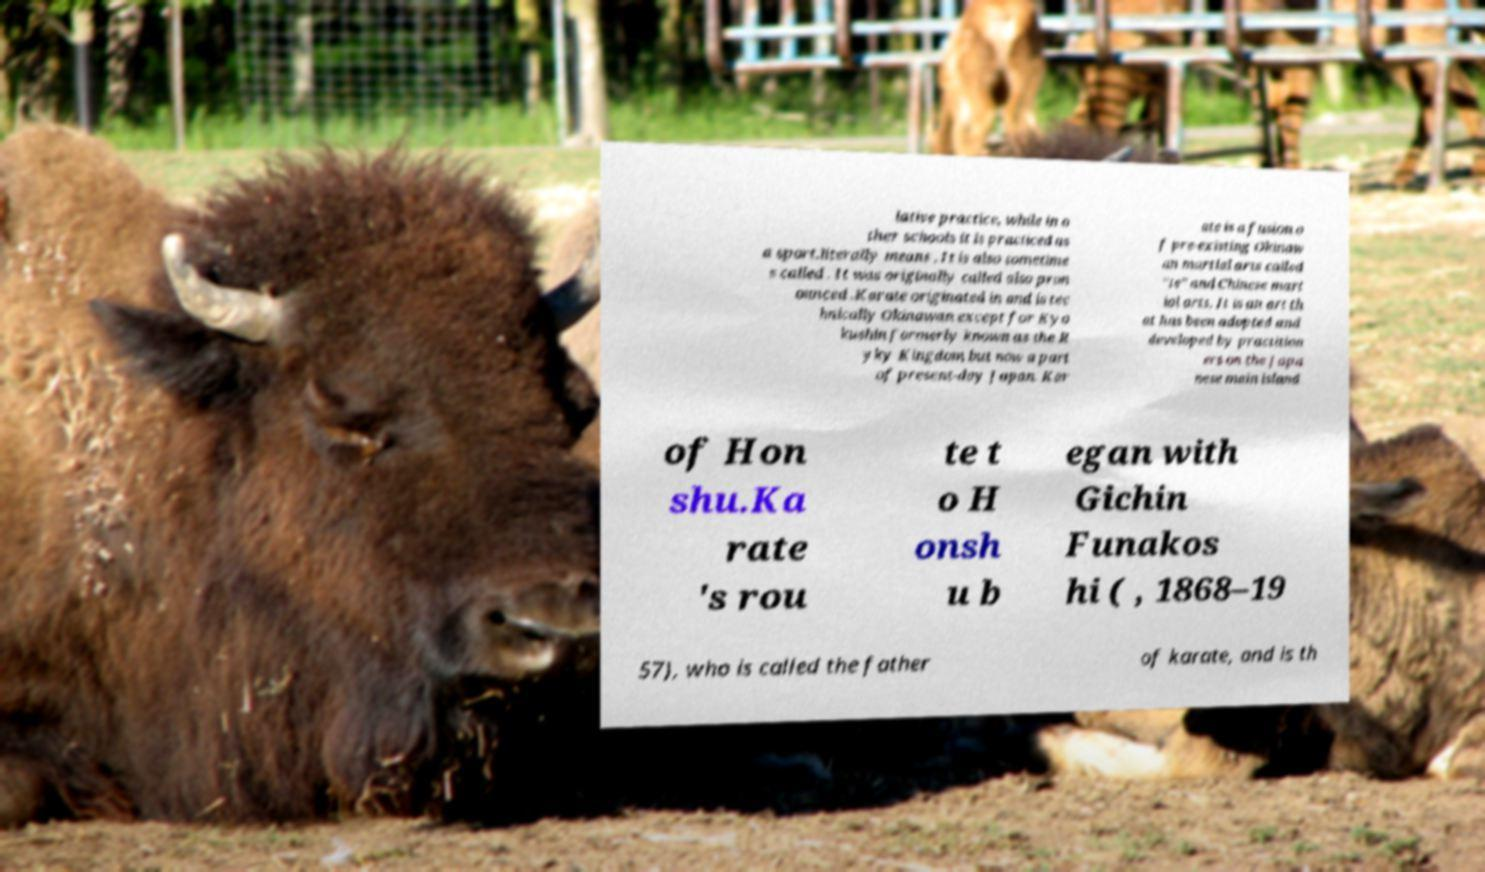Can you read and provide the text displayed in the image?This photo seems to have some interesting text. Can you extract and type it out for me? lative practice, while in o ther schools it is practiced as a sport.literally means . It is also sometime s called . It was originally called also pron ounced .Karate originated in and is tec hnically Okinawan except for Kyo kushin formerly known as the R yky Kingdom but now a part of present-day Japan. Kar ate is a fusion o f pre-existing Okinaw an martial arts called "te" and Chinese mart ial arts. It is an art th at has been adopted and developed by practition ers on the Japa nese main island of Hon shu.Ka rate 's rou te t o H onsh u b egan with Gichin Funakos hi ( , 1868–19 57), who is called the father of karate, and is th 